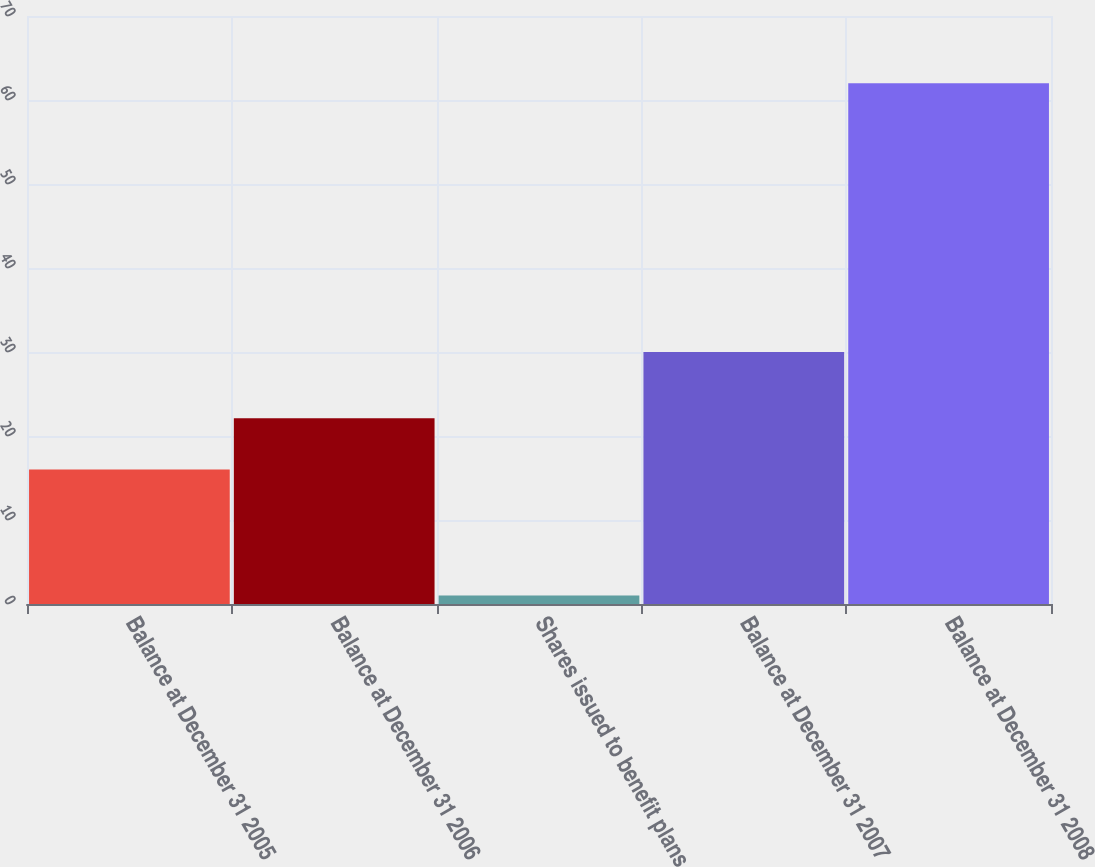<chart> <loc_0><loc_0><loc_500><loc_500><bar_chart><fcel>Balance at December 31 2005<fcel>Balance at December 31 2006<fcel>Shares issued to benefit plans<fcel>Balance at December 31 2007<fcel>Balance at December 31 2008<nl><fcel>16<fcel>22.1<fcel>1<fcel>30<fcel>62<nl></chart> 